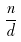Convert formula to latex. <formula><loc_0><loc_0><loc_500><loc_500>\frac { n } { d }</formula> 